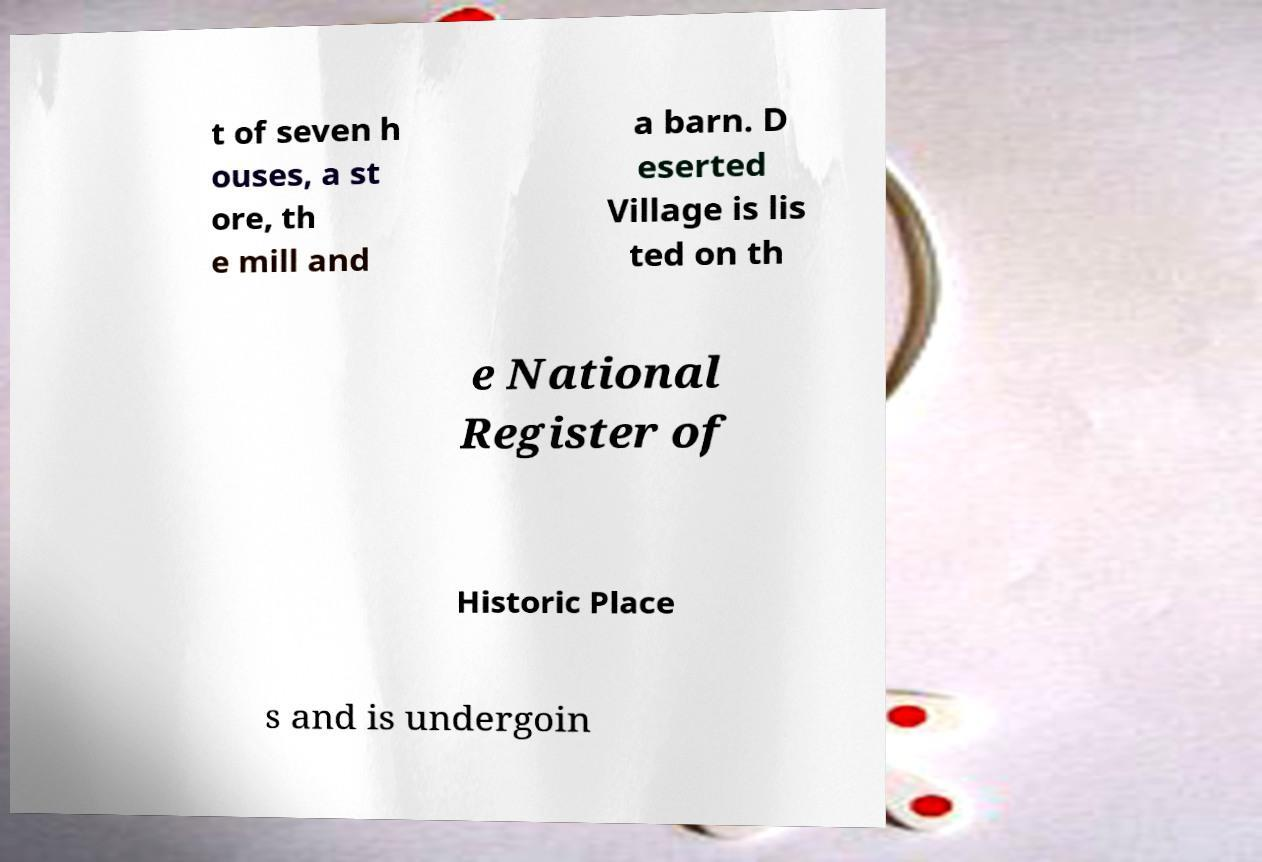What messages or text are displayed in this image? I need them in a readable, typed format. t of seven h ouses, a st ore, th e mill and a barn. D eserted Village is lis ted on th e National Register of Historic Place s and is undergoin 